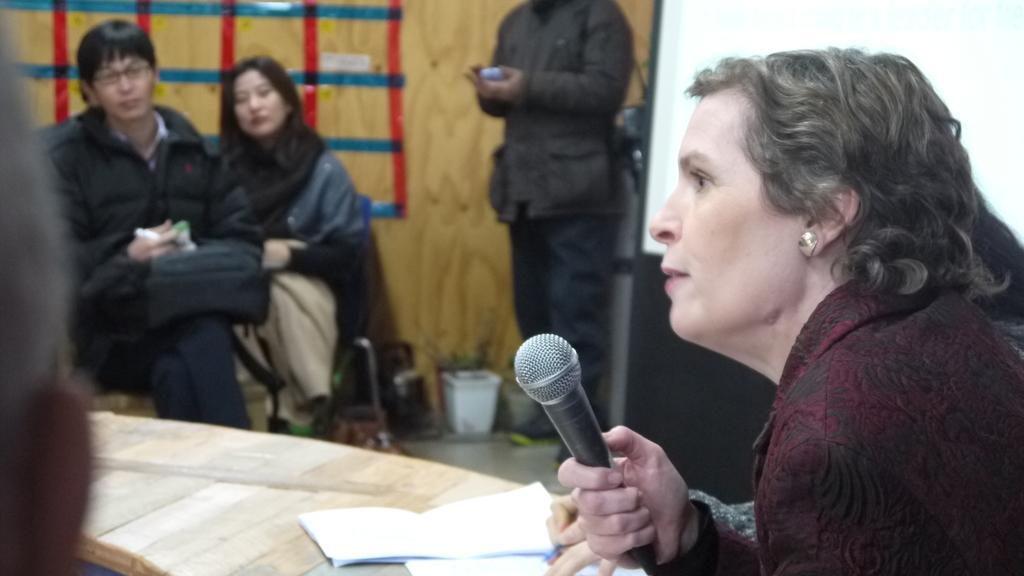Describe this image in one or two sentences. In this picture we can see three persons are sitting on the chairs. She is holding a mike with her hand. This is table. On the table there are books. Here we can see a person who is standing on the floor. On the background there is a wall and this is board. 